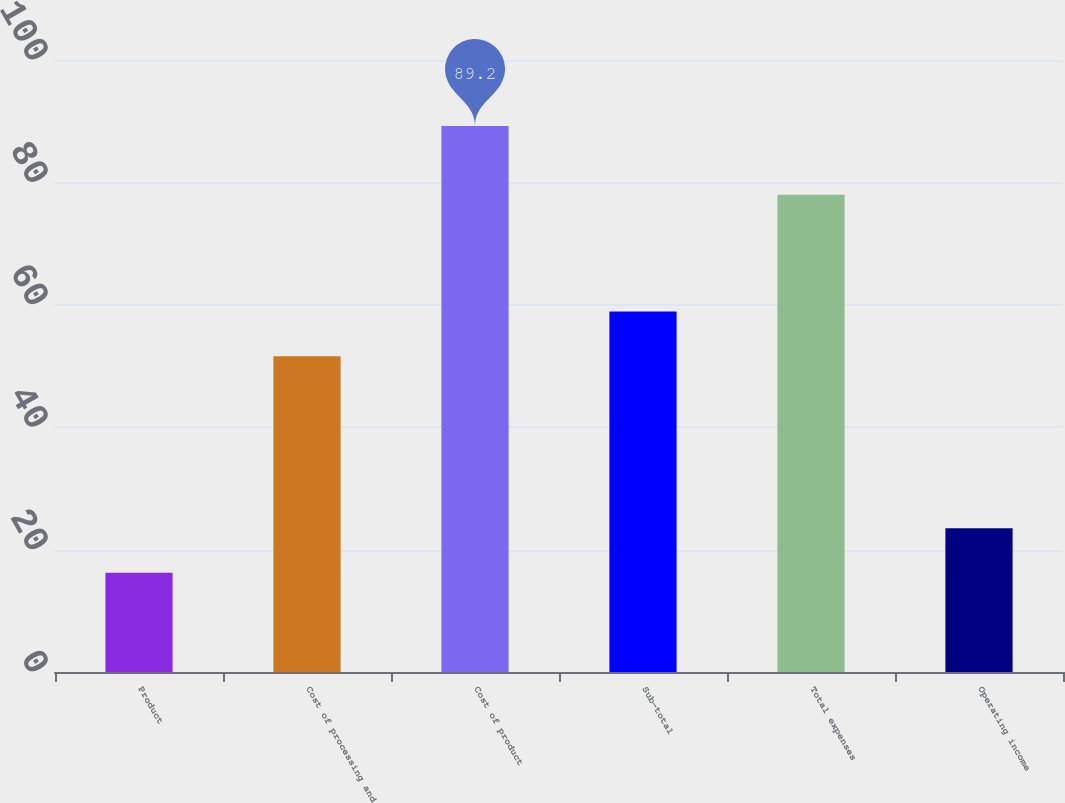Convert chart. <chart><loc_0><loc_0><loc_500><loc_500><bar_chart><fcel>Product<fcel>Cost of processing and<fcel>Cost of product<fcel>Sub-total<fcel>Total expenses<fcel>Operating income<nl><fcel>16.2<fcel>51.6<fcel>89.2<fcel>58.9<fcel>78<fcel>23.5<nl></chart> 